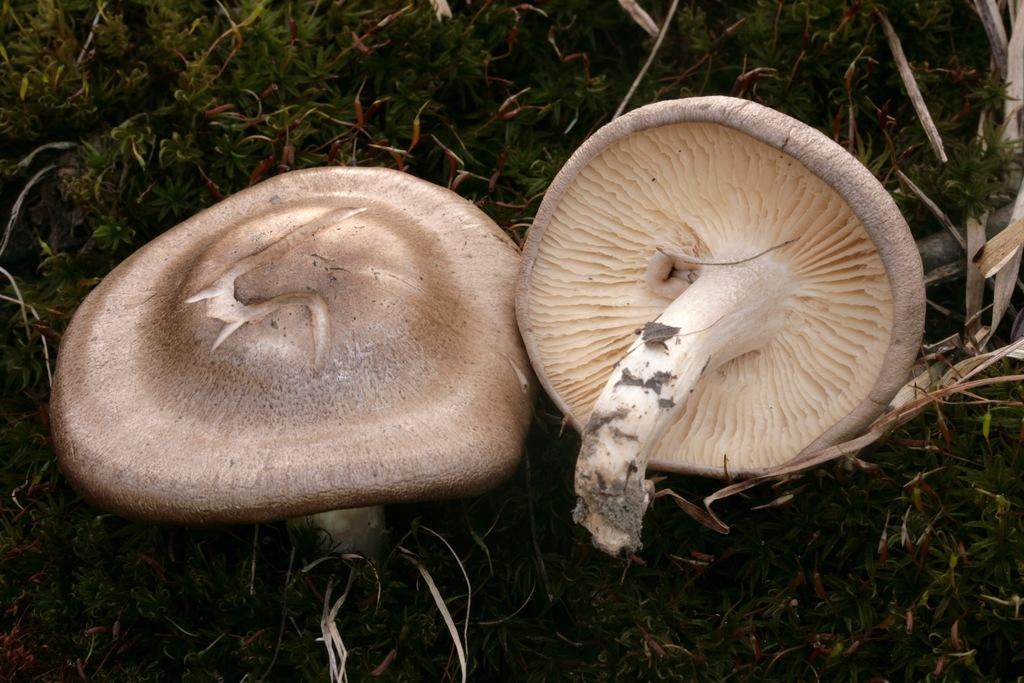What type of vegetation is present on the ground in the image? There are mushrooms on the ground in the image. What can be seen in the background of the image? There is grass visible in the background of the image. What type of beds are being offered to the army in the image? There is no mention of beds or an army in the image; it only features mushrooms on the ground and grass in the background. 